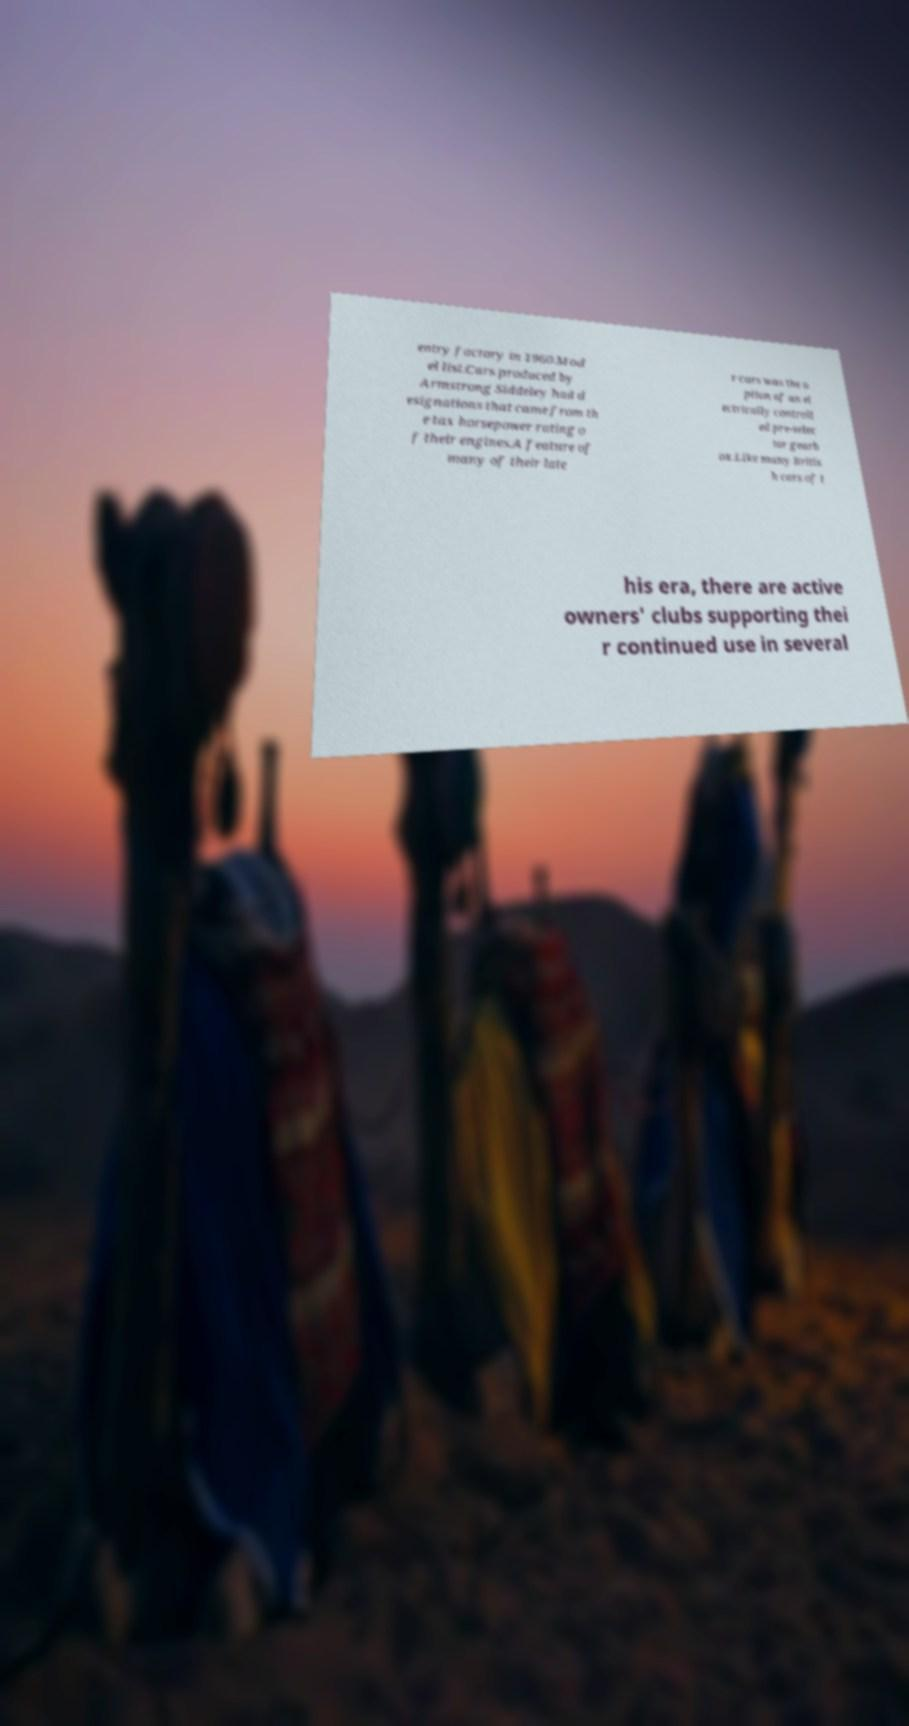For documentation purposes, I need the text within this image transcribed. Could you provide that? entry factory in 1960.Mod el list.Cars produced by Armstrong Siddeley had d esignations that came from th e tax horsepower rating o f their engines.A feature of many of their late r cars was the o ption of an el ectrically controll ed pre-selec tor gearb ox.Like many Britis h cars of t his era, there are active owners' clubs supporting thei r continued use in several 